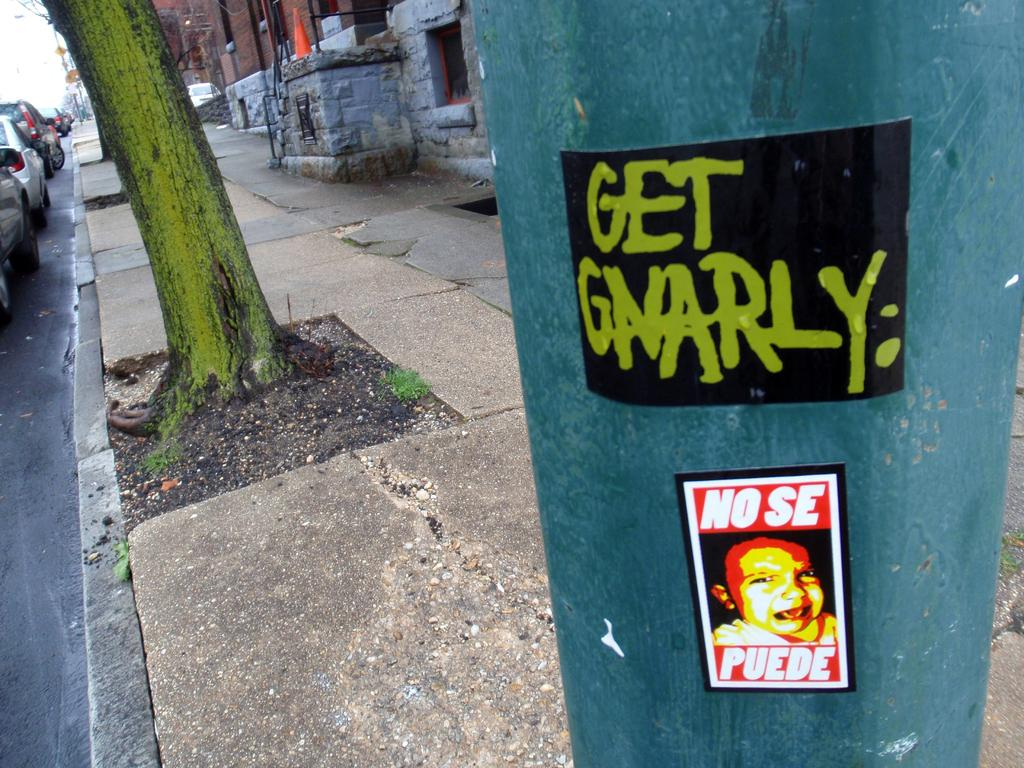Provide a one-sentence caption for the provided image. a post that has the words get gnarly written on it. 